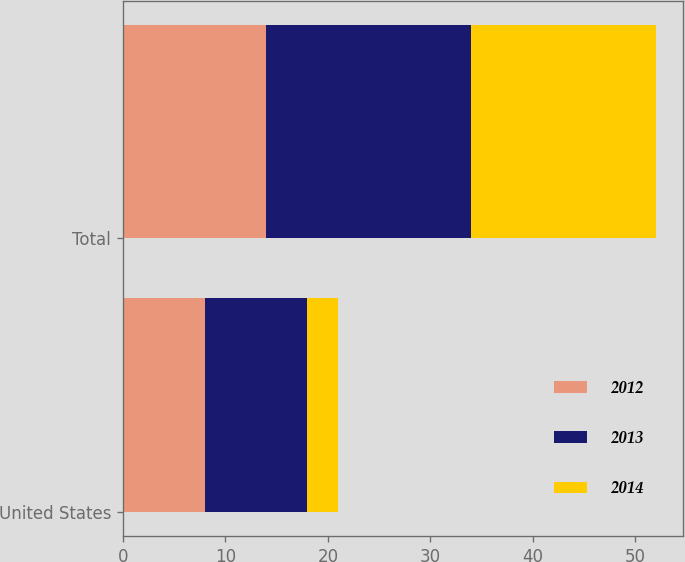Convert chart to OTSL. <chart><loc_0><loc_0><loc_500><loc_500><stacked_bar_chart><ecel><fcel>United States<fcel>Total<nl><fcel>2012<fcel>8<fcel>14<nl><fcel>2013<fcel>10<fcel>20<nl><fcel>2014<fcel>3<fcel>18<nl></chart> 